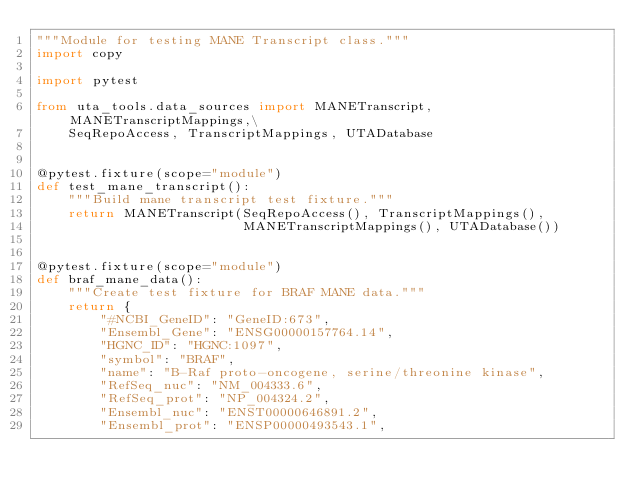<code> <loc_0><loc_0><loc_500><loc_500><_Python_>"""Module for testing MANE Transcript class."""
import copy

import pytest

from uta_tools.data_sources import MANETranscript, MANETranscriptMappings,\
    SeqRepoAccess, TranscriptMappings, UTADatabase


@pytest.fixture(scope="module")
def test_mane_transcript():
    """Build mane transcript test fixture."""
    return MANETranscript(SeqRepoAccess(), TranscriptMappings(),
                          MANETranscriptMappings(), UTADatabase())


@pytest.fixture(scope="module")
def braf_mane_data():
    """Create test fixture for BRAF MANE data."""
    return {
        "#NCBI_GeneID": "GeneID:673",
        "Ensembl_Gene": "ENSG00000157764.14",
        "HGNC_ID": "HGNC:1097",
        "symbol": "BRAF",
        "name": "B-Raf proto-oncogene, serine/threonine kinase",
        "RefSeq_nuc": "NM_004333.6",
        "RefSeq_prot": "NP_004324.2",
        "Ensembl_nuc": "ENST00000646891.2",
        "Ensembl_prot": "ENSP00000493543.1",</code> 